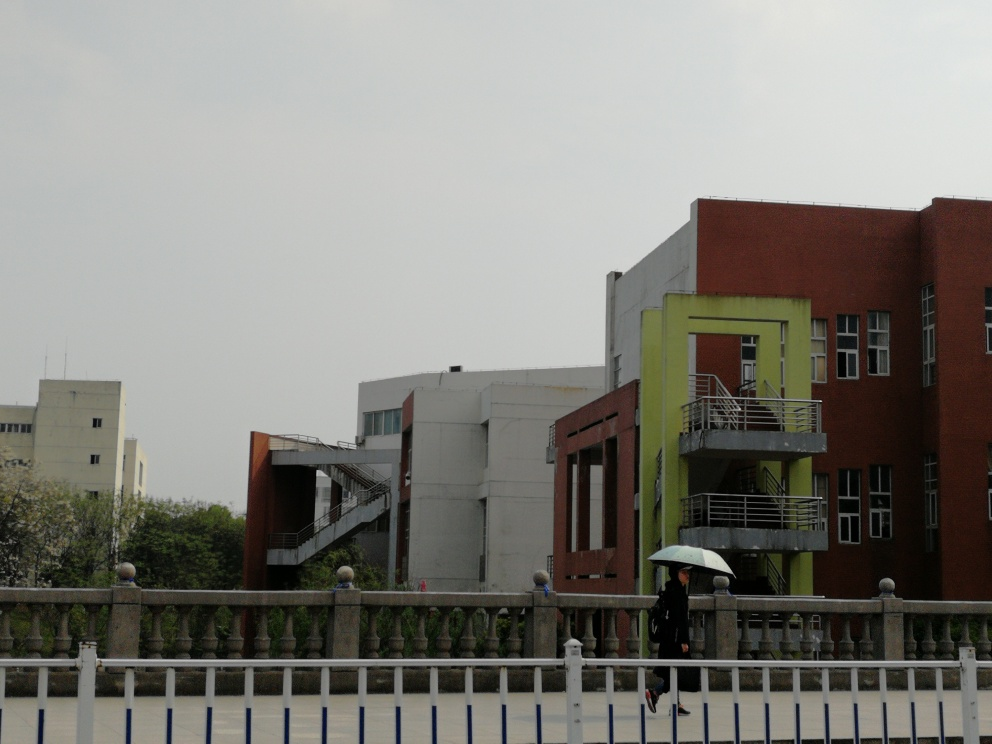What type of buildings are depicted in the image? The buildings in the image appear to be modern commercial or educational structures, characterized by their simplistic architectural design and functional elements like the external staircases. 